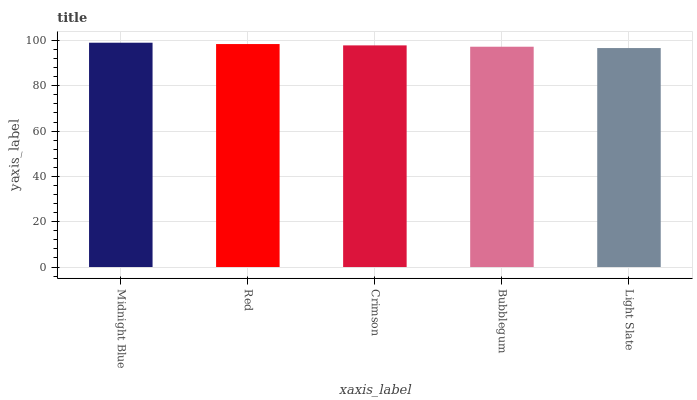Is Light Slate the minimum?
Answer yes or no. Yes. Is Midnight Blue the maximum?
Answer yes or no. Yes. Is Red the minimum?
Answer yes or no. No. Is Red the maximum?
Answer yes or no. No. Is Midnight Blue greater than Red?
Answer yes or no. Yes. Is Red less than Midnight Blue?
Answer yes or no. Yes. Is Red greater than Midnight Blue?
Answer yes or no. No. Is Midnight Blue less than Red?
Answer yes or no. No. Is Crimson the high median?
Answer yes or no. Yes. Is Crimson the low median?
Answer yes or no. Yes. Is Midnight Blue the high median?
Answer yes or no. No. Is Light Slate the low median?
Answer yes or no. No. 